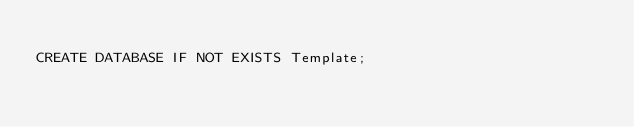Convert code to text. <code><loc_0><loc_0><loc_500><loc_500><_SQL_>
CREATE DATABASE IF NOT EXISTS Template;</code> 